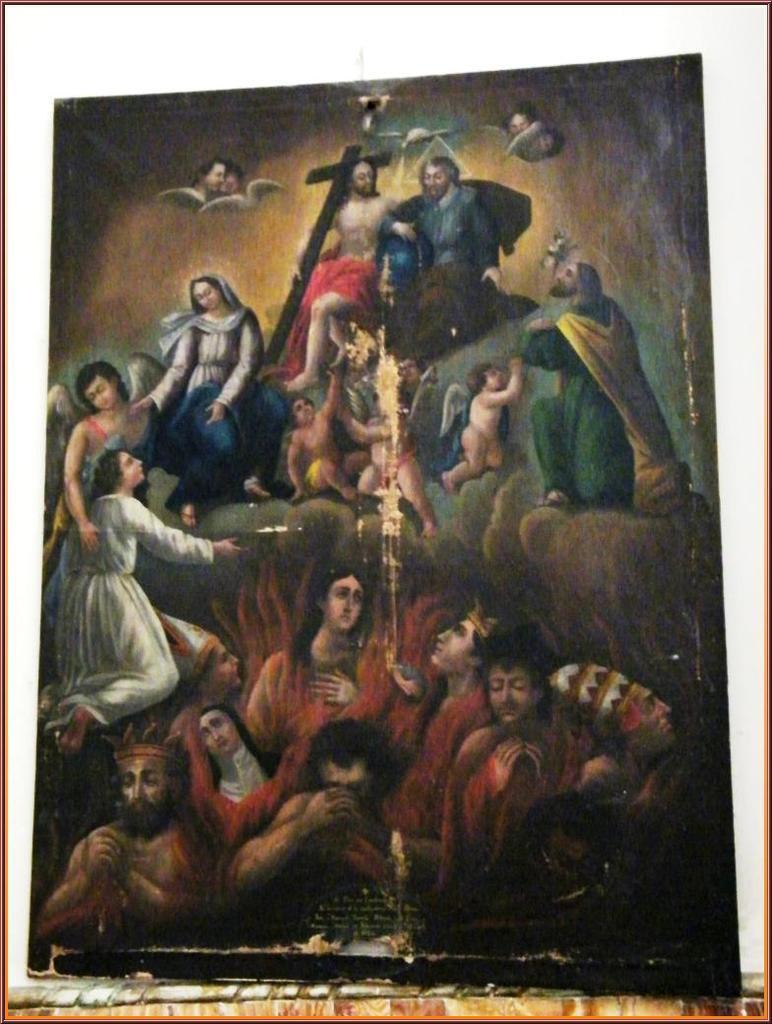Describe this image in one or two sentences. In this picture I can observe a painting. There are some people in this picture. I can observe cross on the top of the picture. 